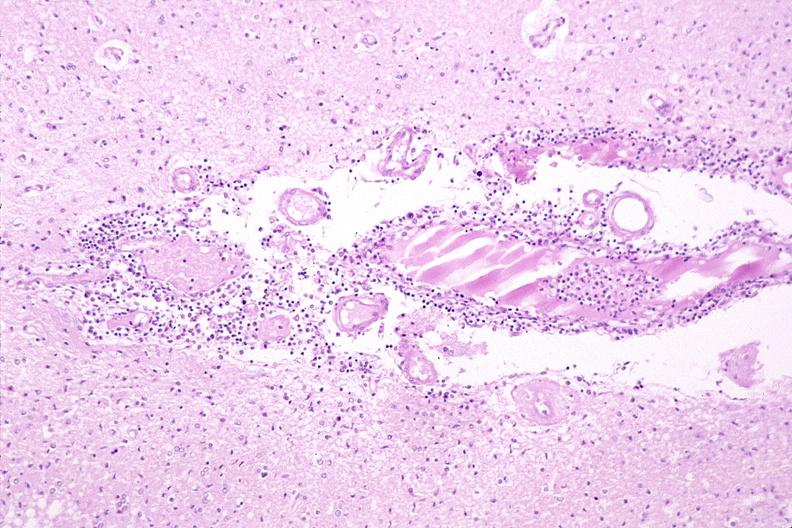does this image show brain, herpes encephalitis?
Answer the question using a single word or phrase. Yes 